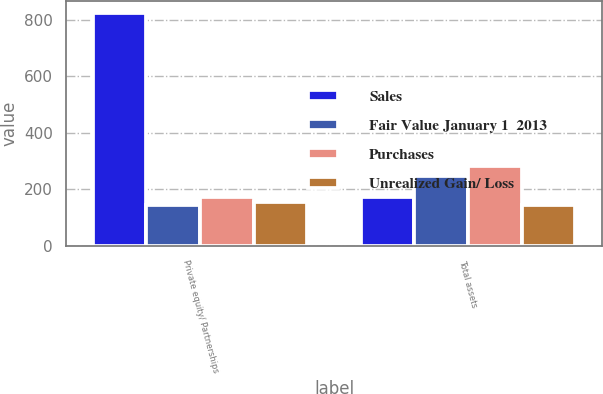Convert chart. <chart><loc_0><loc_0><loc_500><loc_500><stacked_bar_chart><ecel><fcel>Private equity/ Partnerships<fcel>Total assets<nl><fcel>Sales<fcel>824<fcel>174<nl><fcel>Fair Value January 1  2013<fcel>146<fcel>247<nl><fcel>Purchases<fcel>174<fcel>282<nl><fcel>Unrealized Gain/ Loss<fcel>155<fcel>144<nl></chart> 